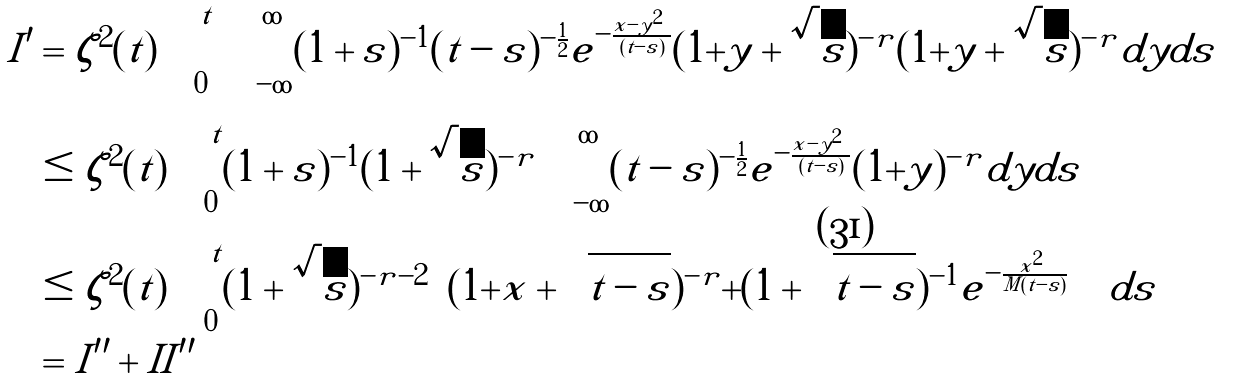Convert formula to latex. <formula><loc_0><loc_0><loc_500><loc_500>I ^ { \prime } & = \zeta ^ { 2 } ( t ) \int _ { 0 } ^ { t } \int _ { - \infty } ^ { \infty } ( 1 + s ) ^ { - 1 } ( t - s ) ^ { - \frac { 1 } { 2 } } e ^ { - \frac { | x - y | ^ { 2 } } { ( t - s ) } } ( 1 + | y | + \sqrt { s } ) ^ { - r } ( 1 + | y | + \sqrt { s } ) ^ { - r } d y d s \\ & \leq \zeta ^ { 2 } ( t ) \int _ { 0 } ^ { t } ( 1 + s ) ^ { - 1 } ( 1 + \sqrt { s } ) ^ { - r } \int _ { - \infty } ^ { \infty } ( t - s ) ^ { - \frac { 1 } { 2 } } e ^ { - \frac { | x - y | ^ { 2 } } { ( t - s ) } } ( 1 + | y | ) ^ { - r } d y d s \\ & \leq \zeta ^ { 2 } ( t ) \int _ { 0 } ^ { t } ( 1 + \sqrt { s } ) ^ { - r - 2 } \left [ ( 1 + | x | + \sqrt { t - s } ) ^ { - r } + ( 1 + \sqrt { t - s } ) ^ { - 1 } e ^ { - \frac { | x | ^ { 2 } } { M ( t - s ) } } \right ] d s \\ & = I ^ { \prime \prime } + I I ^ { \prime \prime }</formula> 